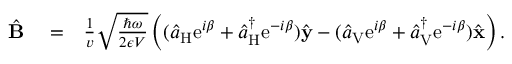<formula> <loc_0><loc_0><loc_500><loc_500>\begin{array} { r l r } { \hat { B } } & = } & { \frac { 1 } { v } \sqrt { \frac { \hbar { \omega } } { 2 \epsilon V } } \left ( ( \hat { a } _ { H } e ^ { i \beta } + \hat { a } _ { H } ^ { \dagger } e ^ { - i \beta } ) \hat { y } - ( \hat { a } _ { V } e ^ { i \beta } + \hat { a } _ { V } ^ { \dagger } e ^ { - i \beta } ) \hat { x } \right ) . } \end{array}</formula> 